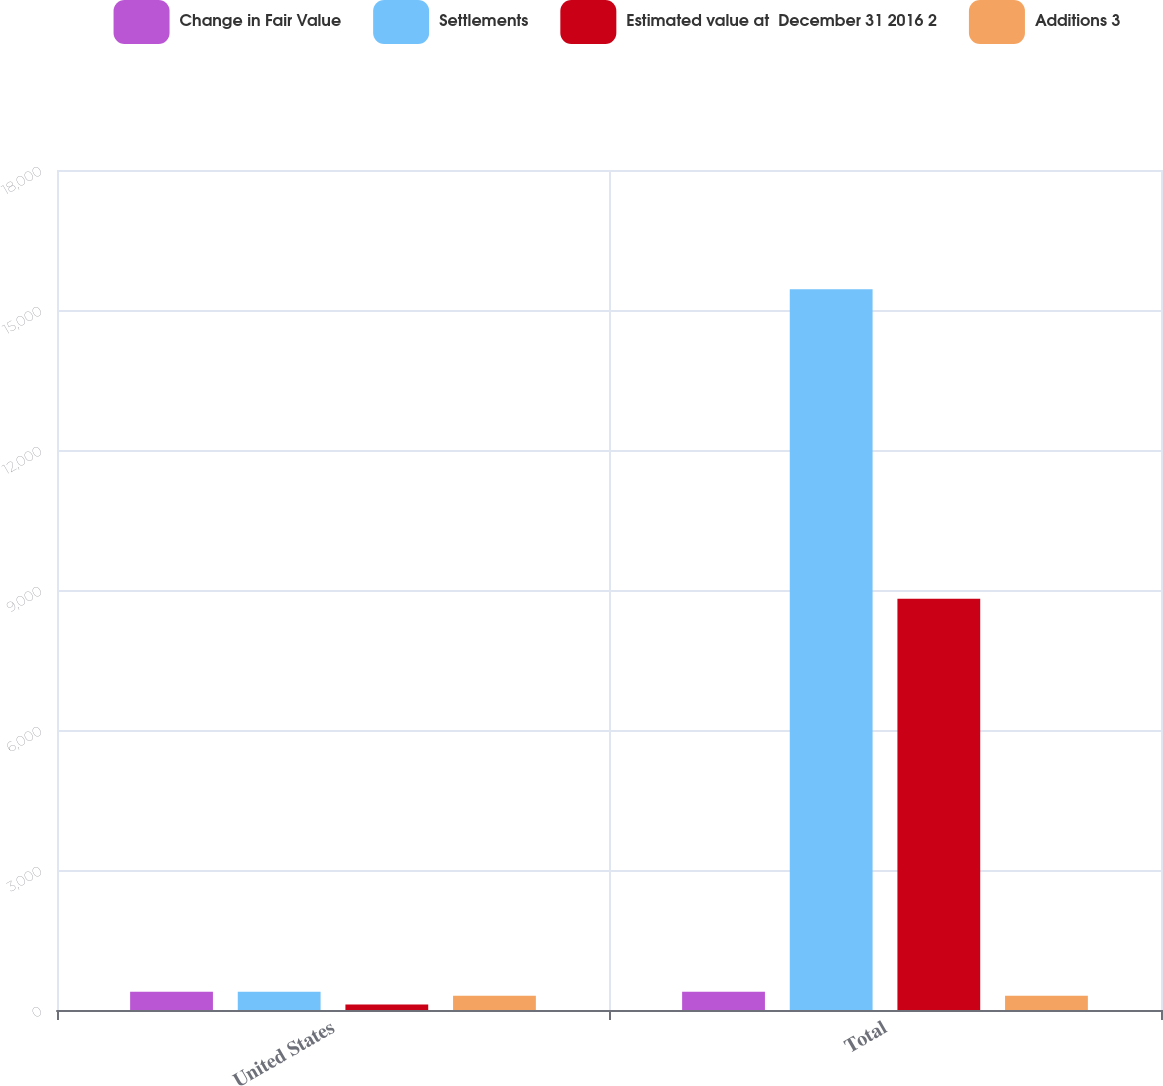Convert chart. <chart><loc_0><loc_0><loc_500><loc_500><stacked_bar_chart><ecel><fcel>United States<fcel>Total<nl><fcel>Change in Fair Value<fcel>393<fcel>393<nl><fcel>Settlements<fcel>393<fcel>15444<nl><fcel>Estimated value at  December 31 2016 2<fcel>119<fcel>8811<nl><fcel>Additions 3<fcel>306<fcel>306<nl></chart> 